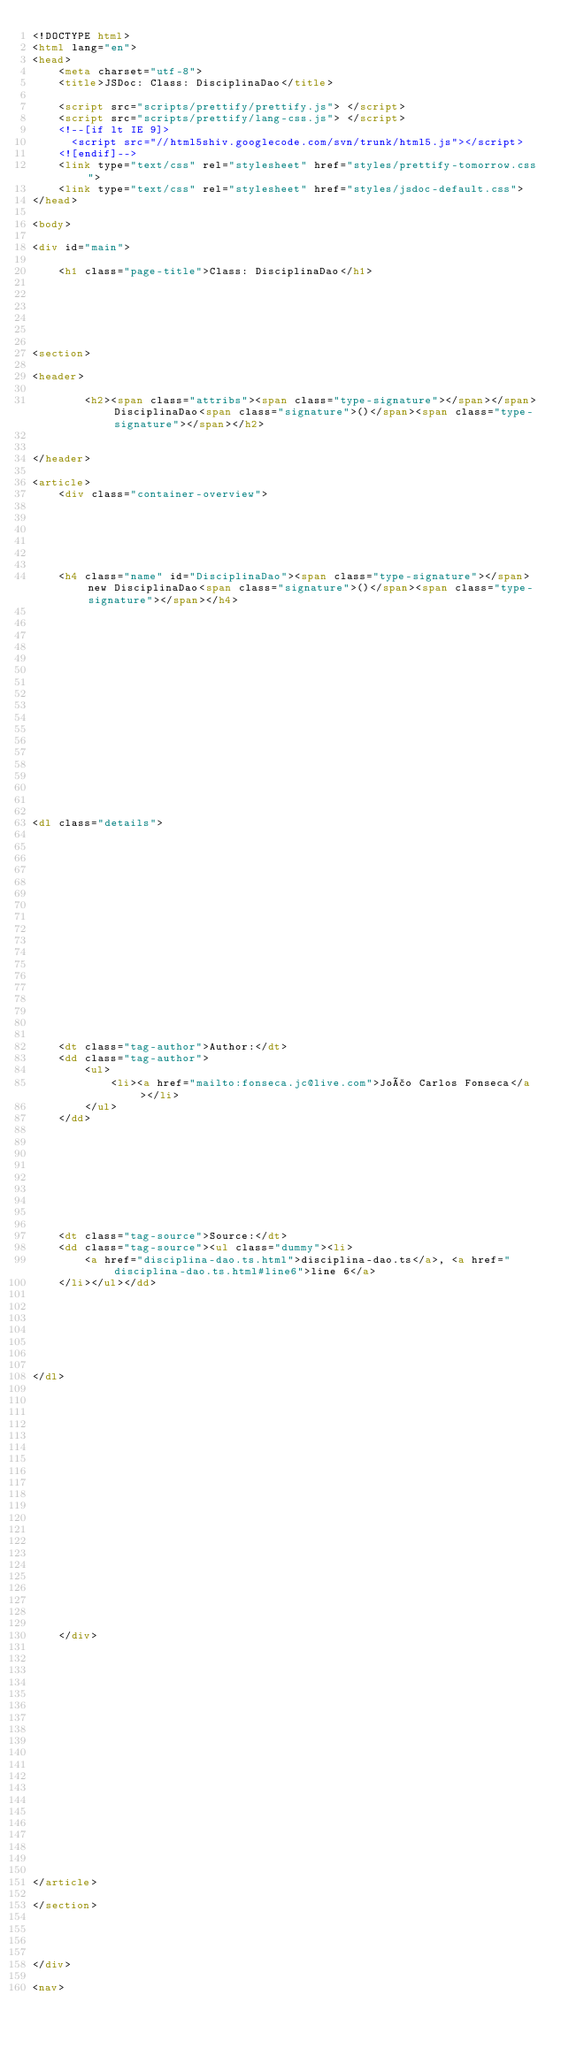<code> <loc_0><loc_0><loc_500><loc_500><_HTML_><!DOCTYPE html>
<html lang="en">
<head>
    <meta charset="utf-8">
    <title>JSDoc: Class: DisciplinaDao</title>

    <script src="scripts/prettify/prettify.js"> </script>
    <script src="scripts/prettify/lang-css.js"> </script>
    <!--[if lt IE 9]>
      <script src="//html5shiv.googlecode.com/svn/trunk/html5.js"></script>
    <![endif]-->
    <link type="text/css" rel="stylesheet" href="styles/prettify-tomorrow.css">
    <link type="text/css" rel="stylesheet" href="styles/jsdoc-default.css">
</head>

<body>

<div id="main">

    <h1 class="page-title">Class: DisciplinaDao</h1>

    




<section>

<header>
    
        <h2><span class="attribs"><span class="type-signature"></span></span>DisciplinaDao<span class="signature">()</span><span class="type-signature"></span></h2>
        
    
</header>

<article>
    <div class="container-overview">
    
        

    

    
    <h4 class="name" id="DisciplinaDao"><span class="type-signature"></span>new DisciplinaDao<span class="signature">()</span><span class="type-signature"></span></h4>
    

    















<dl class="details">

    

    

    

    

    

    

    

    

    
    <dt class="tag-author">Author:</dt>
    <dd class="tag-author">
        <ul>
            <li><a href="mailto:fonseca.jc@live.com">João Carlos Fonseca</a></li>
        </ul>
    </dd>
    

    

    

    

    
    <dt class="tag-source">Source:</dt>
    <dd class="tag-source"><ul class="dummy"><li>
        <a href="disciplina-dao.ts.html">disciplina-dao.ts</a>, <a href="disciplina-dao.ts.html#line6">line 6</a>
    </li></ul></dd>
    

    

    

    
</dl>




















    
    </div>

    

    

    

    

    

    

    

    

    

    
</article>

</section>




</div>

<nav></code> 